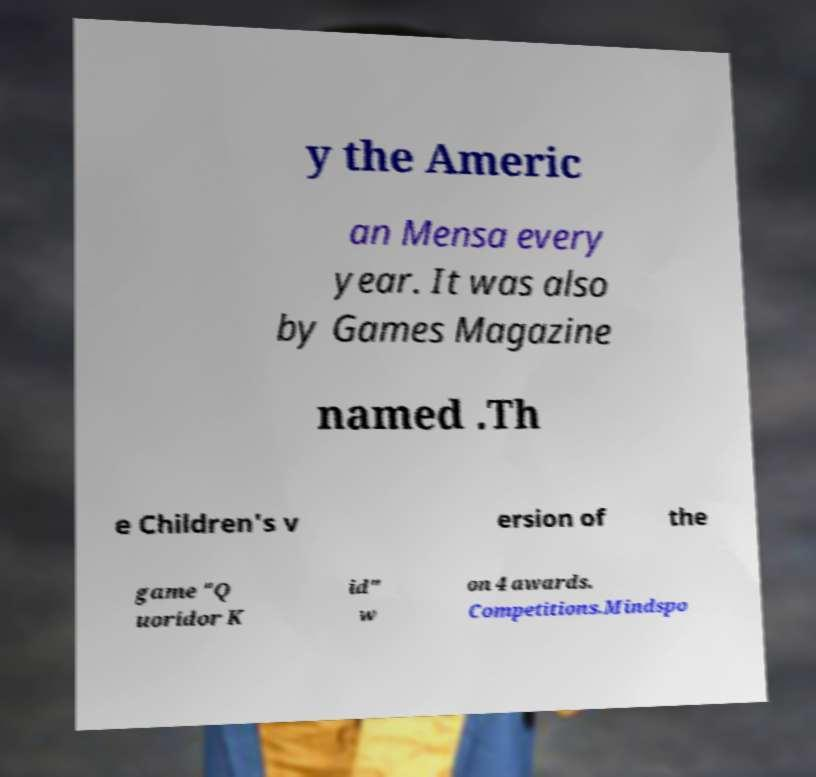Please read and relay the text visible in this image. What does it say? y the Americ an Mensa every year. It was also by Games Magazine named .Th e Children's v ersion of the game "Q uoridor K id" w on 4 awards. Competitions.Mindspo 